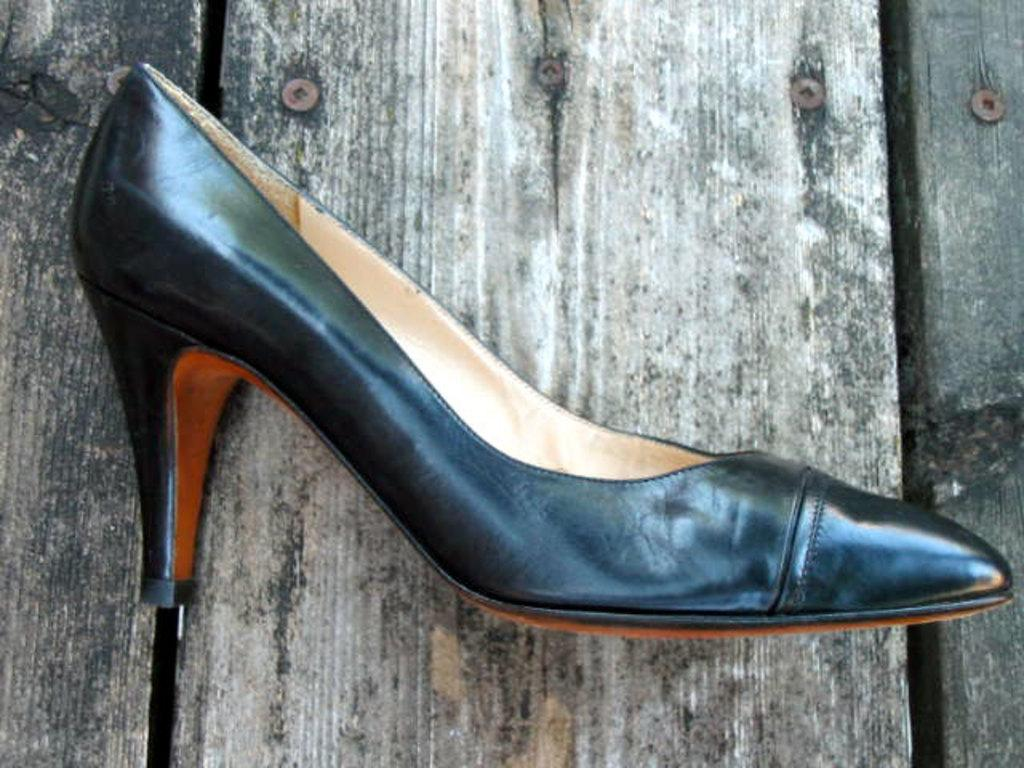What type of object is placed on the table in the image? There is footwear present on a table in the image. Can you describe the footwear in more detail? Unfortunately, the image does not provide enough detail to describe the footwear further. What type of calculator is visible on the table in the image? There is no calculator present in the image; it only features footwear on a table. 